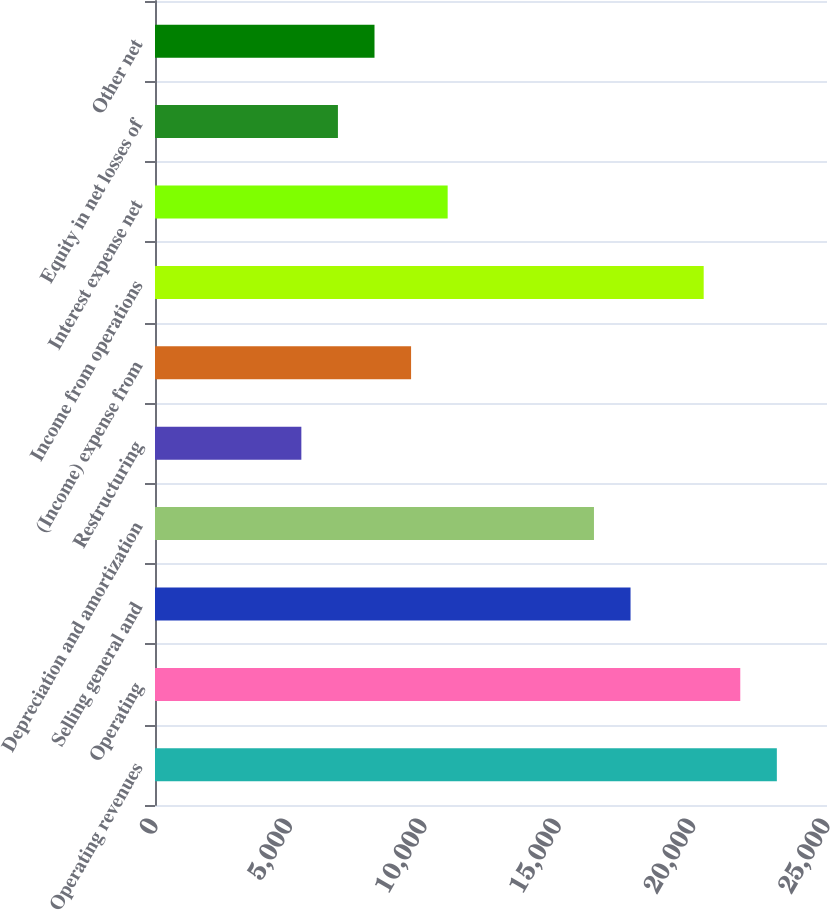<chart> <loc_0><loc_0><loc_500><loc_500><bar_chart><fcel>Operating revenues<fcel>Operating<fcel>Selling general and<fcel>Depreciation and amortization<fcel>Restructuring<fcel>(Income) expense from<fcel>Income from operations<fcel>Interest expense net<fcel>Equity in net losses of<fcel>Other net<nl><fcel>23134.2<fcel>21773.5<fcel>17691.3<fcel>16330.5<fcel>5444.6<fcel>9526.82<fcel>20412.7<fcel>10887.6<fcel>6805.34<fcel>8166.08<nl></chart> 